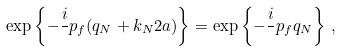<formula> <loc_0><loc_0><loc_500><loc_500>\exp \left \{ - \frac { i } { } p _ { f } ( q _ { N } + k _ { N } 2 a ) \right \} = \exp \left \{ - \frac { i } { } p _ { f } q _ { N } \right \} \, ,</formula> 